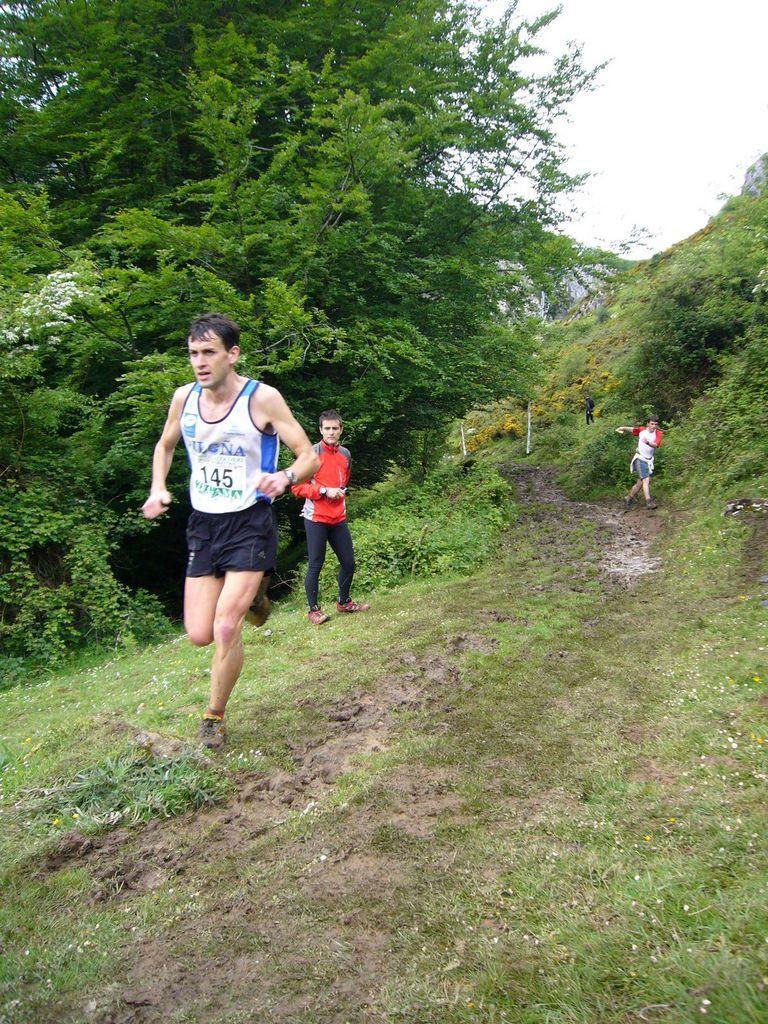How would you summarize this image in a sentence or two? In this image, I can see two persons running and a person standing on the grass. There are trees and plants. In the background, there is the sky. 